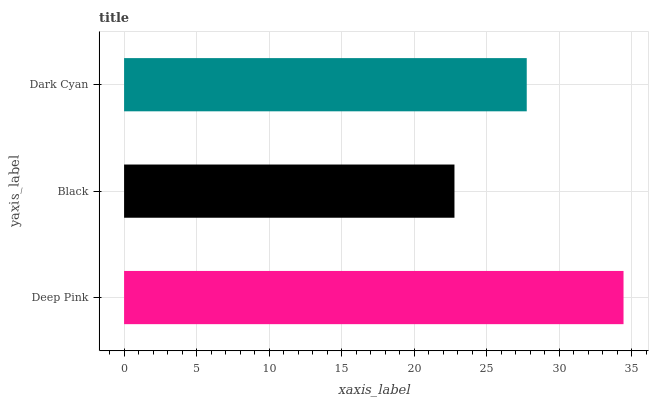Is Black the minimum?
Answer yes or no. Yes. Is Deep Pink the maximum?
Answer yes or no. Yes. Is Dark Cyan the minimum?
Answer yes or no. No. Is Dark Cyan the maximum?
Answer yes or no. No. Is Dark Cyan greater than Black?
Answer yes or no. Yes. Is Black less than Dark Cyan?
Answer yes or no. Yes. Is Black greater than Dark Cyan?
Answer yes or no. No. Is Dark Cyan less than Black?
Answer yes or no. No. Is Dark Cyan the high median?
Answer yes or no. Yes. Is Dark Cyan the low median?
Answer yes or no. Yes. Is Deep Pink the high median?
Answer yes or no. No. Is Black the low median?
Answer yes or no. No. 